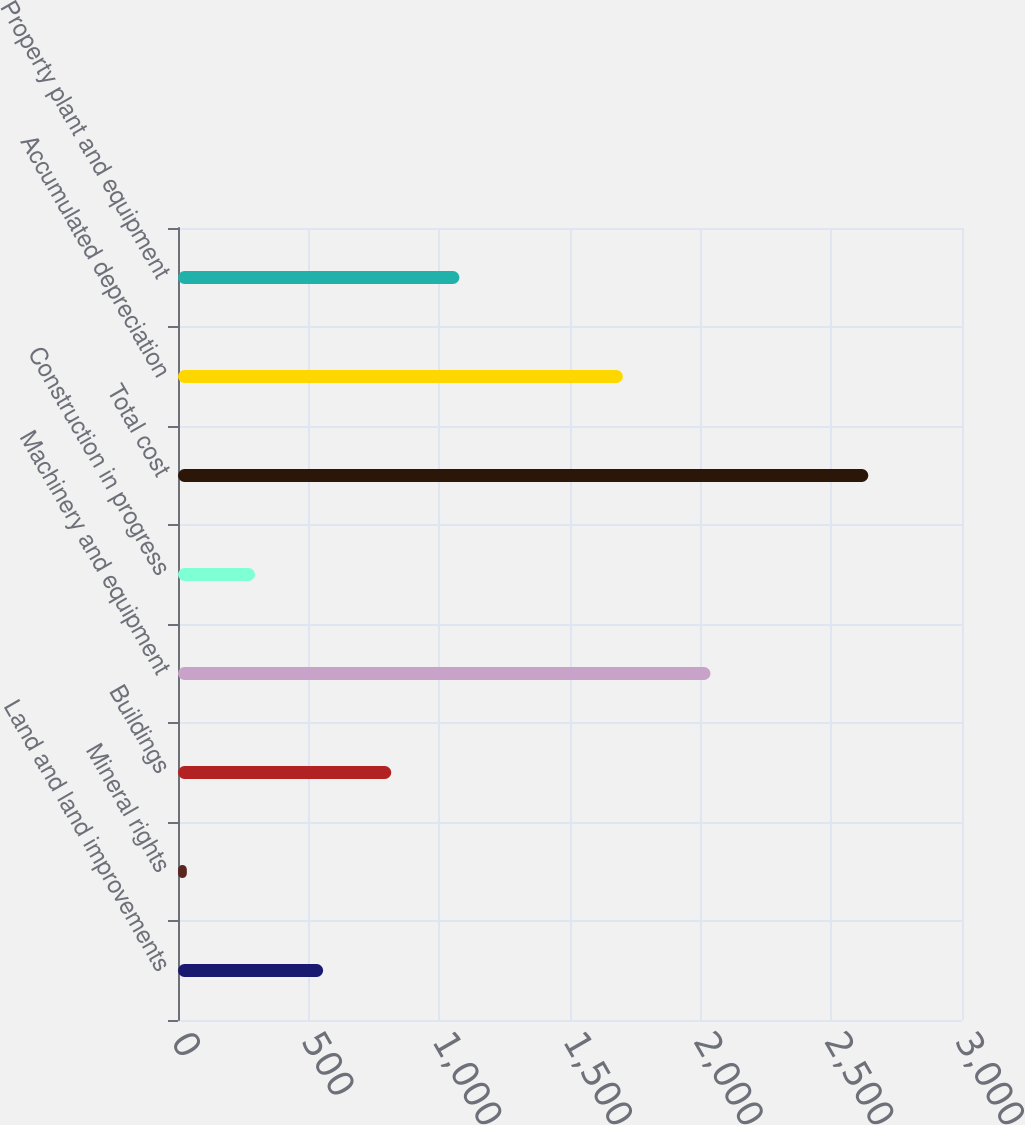Convert chart to OTSL. <chart><loc_0><loc_0><loc_500><loc_500><bar_chart><fcel>Land and land improvements<fcel>Mineral rights<fcel>Buildings<fcel>Machinery and equipment<fcel>Construction in progress<fcel>Total cost<fcel>Accumulated depreciation<fcel>Property plant and equipment<nl><fcel>555.34<fcel>33.8<fcel>816.11<fcel>2037.6<fcel>294.57<fcel>2641.5<fcel>1702.3<fcel>1076.88<nl></chart> 